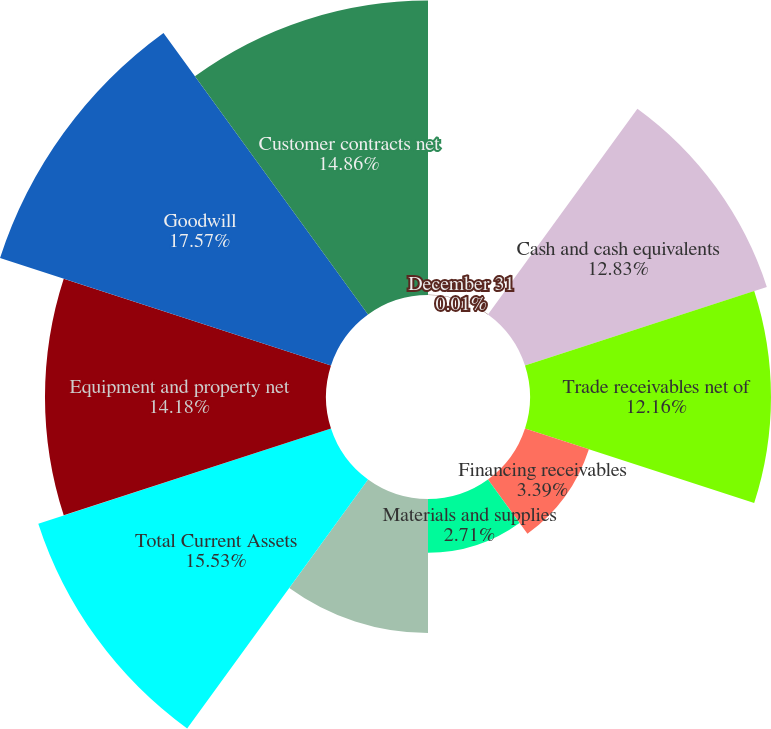Convert chart. <chart><loc_0><loc_0><loc_500><loc_500><pie_chart><fcel>December 31<fcel>Cash and cash equivalents<fcel>Trade receivables net of<fcel>Financing receivables<fcel>Materials and supplies<fcel>Other current assets<fcel>Total Current Assets<fcel>Equipment and property net<fcel>Goodwill<fcel>Customer contracts net<nl><fcel>0.01%<fcel>12.83%<fcel>12.16%<fcel>3.39%<fcel>2.71%<fcel>6.76%<fcel>15.53%<fcel>14.18%<fcel>17.56%<fcel>14.86%<nl></chart> 